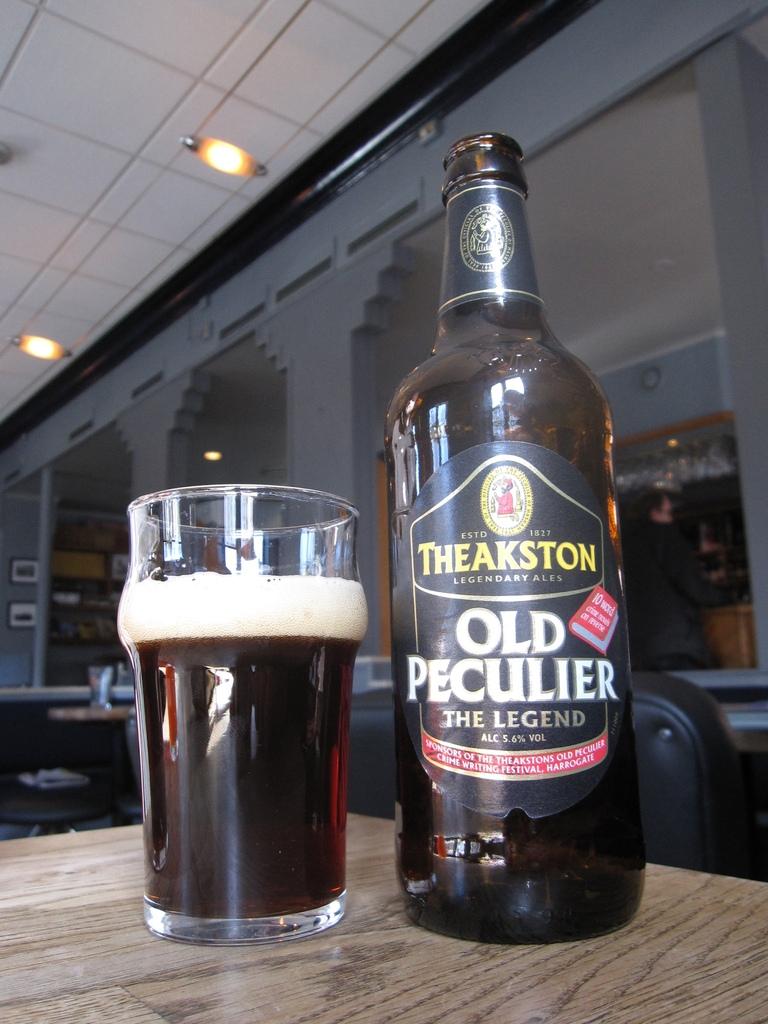What percent alcohol is this product?
Provide a short and direct response. 5.6. 